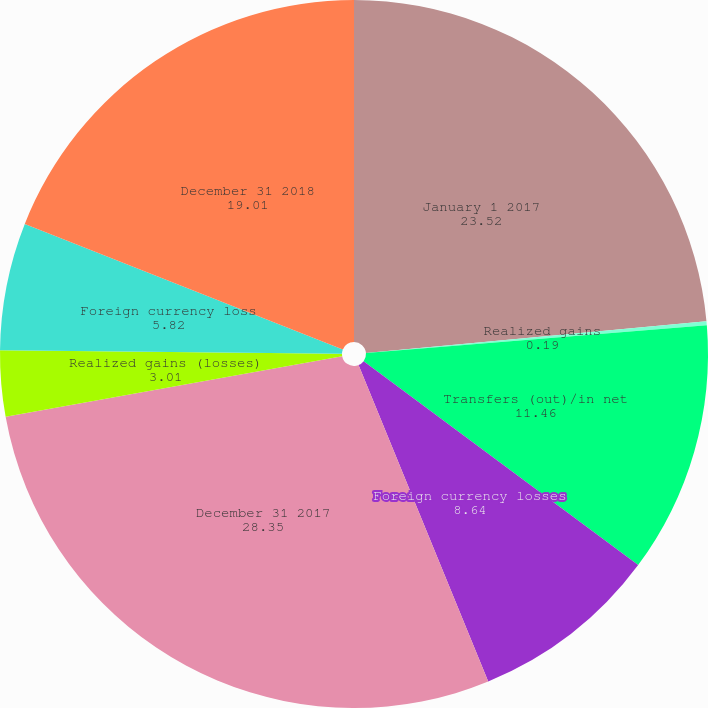Convert chart to OTSL. <chart><loc_0><loc_0><loc_500><loc_500><pie_chart><fcel>January 1 2017<fcel>Realized gains<fcel>Transfers (out)/in net<fcel>Foreign currency losses<fcel>December 31 2017<fcel>Realized gains (losses)<fcel>Foreign currency loss<fcel>December 31 2018<nl><fcel>23.52%<fcel>0.19%<fcel>11.46%<fcel>8.64%<fcel>28.35%<fcel>3.01%<fcel>5.82%<fcel>19.01%<nl></chart> 